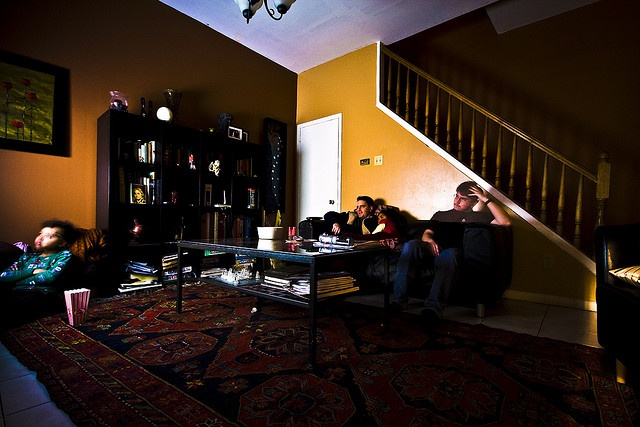Describe the objects in this image and their specific colors. I can see dining table in black, white, gray, and navy tones, people in black, maroon, brown, and lightpink tones, couch in black, white, olive, and orange tones, chair in black, ivory, olive, and maroon tones, and people in black, teal, maroon, and white tones in this image. 